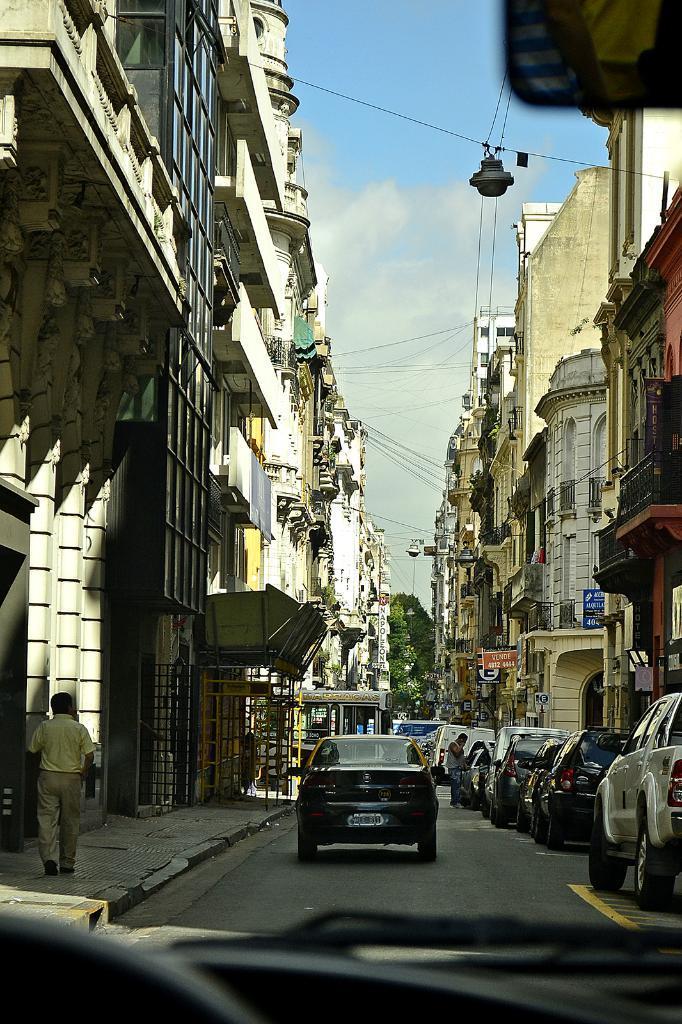In one or two sentences, can you explain what this image depicts? In this image we can see a group of cars parked on the road. To the left side of the image we can see a person wearing a yellow t shirt is walking on the path. In the background, we can see a group of buildings, trees and sky. 